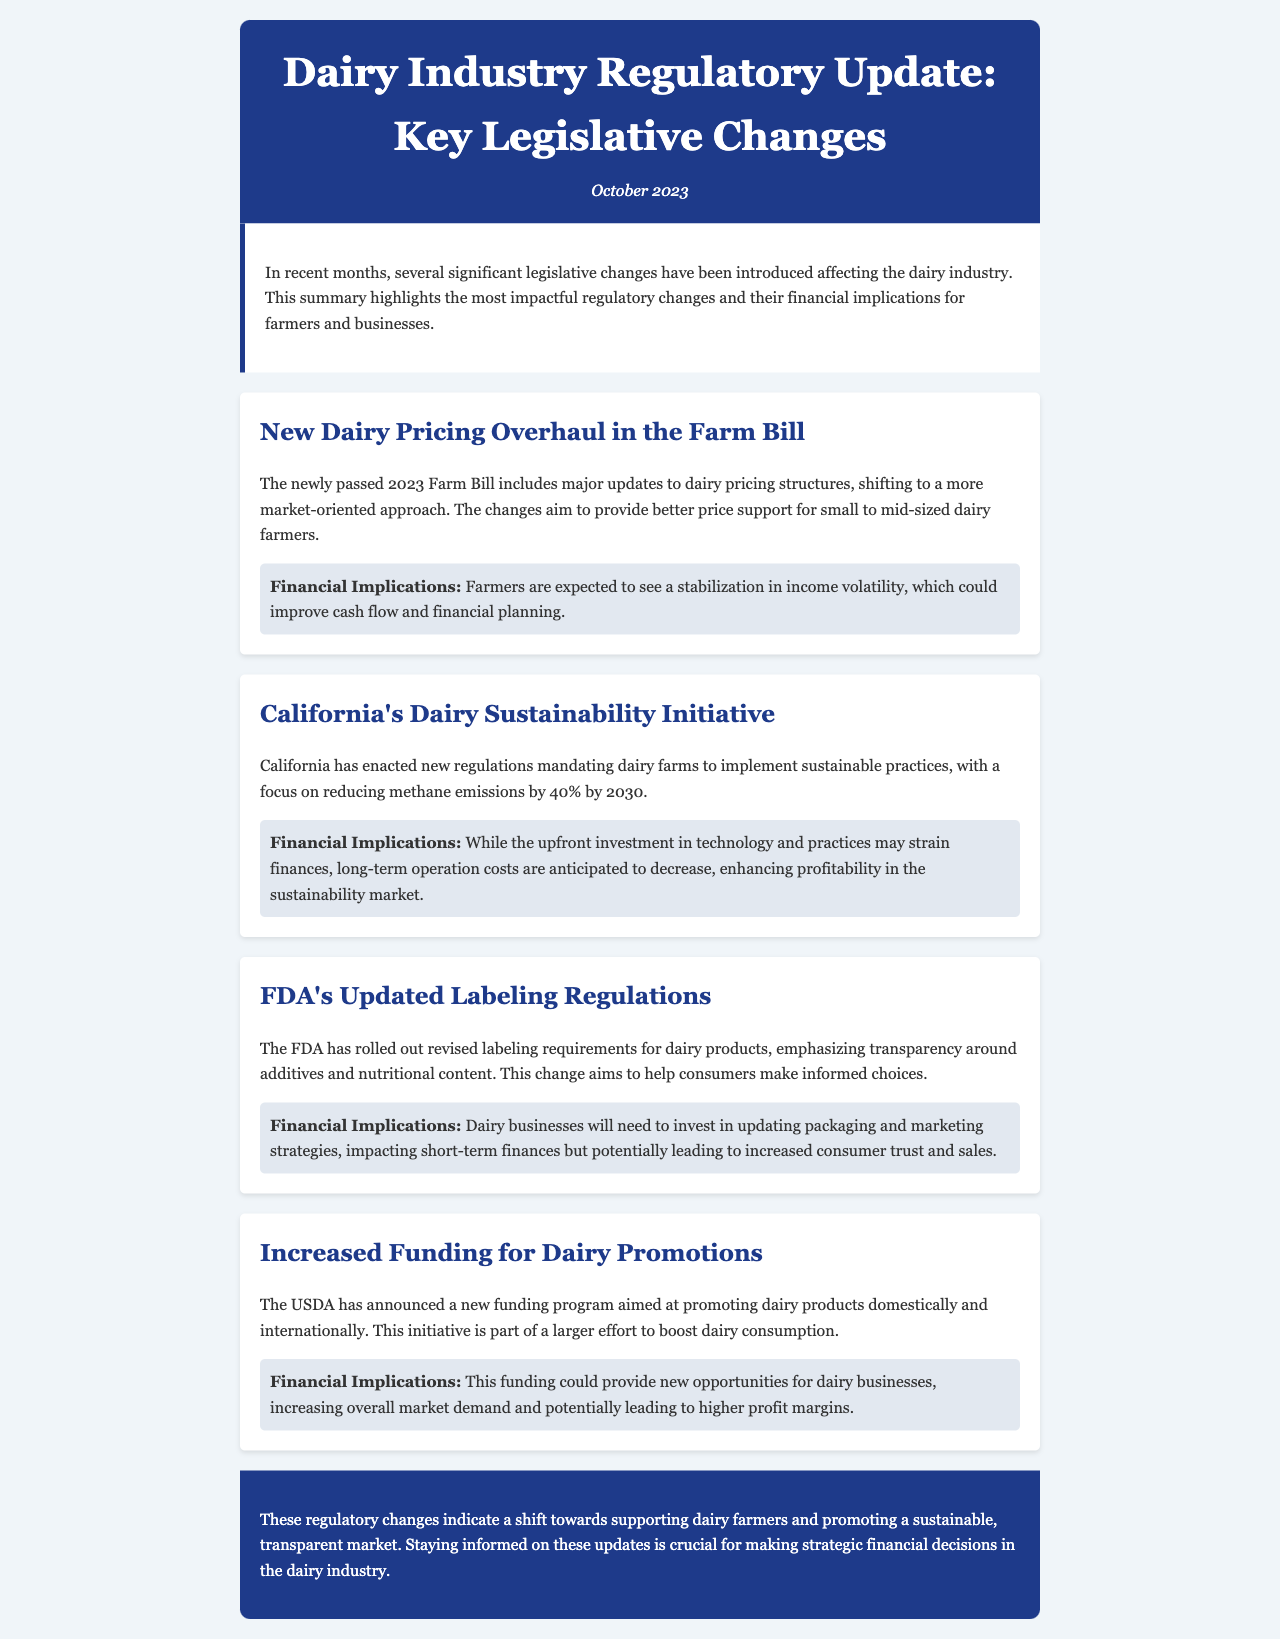What is the title of the newsletter? The title of the newsletter is found in the header section that summarizes the content of the document, which focuses on recent legislative changes in the dairy industry.
Answer: Dairy Industry Regulatory Update: Key Legislative Changes When was the newsletter published? The publication date is located in the header section of the document.
Answer: October 2023 What is the primary focus of the new Dairy Pricing Overhaul in the Farm Bill? This primary focus is outlined in the specific update section relating to the Farm Bill, summarizing its objectives.
Answer: Market-oriented approach What is the target percentage reduction of methane emissions stated in California's Dairy Sustainability Initiative? The percentage for emission reduction is explicitly mentioned in the corresponding update about California's regulations.
Answer: 40% Which organization announced the new funding program aimed at promoting dairy products? The organization responsible for the announcement is specified in the section discussing funding opportunities for dairy promotions.
Answer: USDA What are dairy businesses expected to invest in due to the FDA's Updated Labeling Regulations? The expected investment is detailed in the section outlining the implications of the FDA's regulations on dairy products.
Answer: Packaging and marketing strategies What financial impact might California's Dairy Sustainability Initiative have in the long term? The long-term financial implications are indicated in the update regarding sustainability practices.
Answer: Decrease in operation costs What could the USDA funding program lead to for dairy businesses? The potential outcomes of the USDA funding program for businesses are described in the respective financial implications section.
Answer: Higher profit margins What is the overall indication of the regulatory changes discussed in the newsletter? The conclusion summarizes the overarching theme of the regulatory changes and their purpose in the market.
Answer: Supporting dairy farmers 